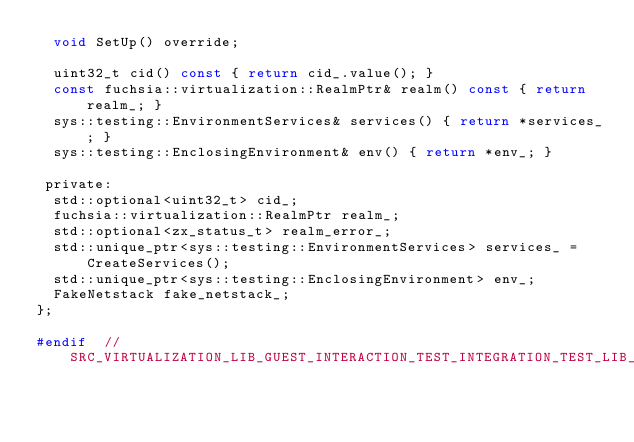Convert code to text. <code><loc_0><loc_0><loc_500><loc_500><_C_>  void SetUp() override;

  uint32_t cid() const { return cid_.value(); }
  const fuchsia::virtualization::RealmPtr& realm() const { return realm_; }
  sys::testing::EnvironmentServices& services() { return *services_; }
  sys::testing::EnclosingEnvironment& env() { return *env_; }

 private:
  std::optional<uint32_t> cid_;
  fuchsia::virtualization::RealmPtr realm_;
  std::optional<zx_status_t> realm_error_;
  std::unique_ptr<sys::testing::EnvironmentServices> services_ = CreateServices();
  std::unique_ptr<sys::testing::EnclosingEnvironment> env_;
  FakeNetstack fake_netstack_;
};

#endif  // SRC_VIRTUALIZATION_LIB_GUEST_INTERACTION_TEST_INTEGRATION_TEST_LIB_H_
</code> 